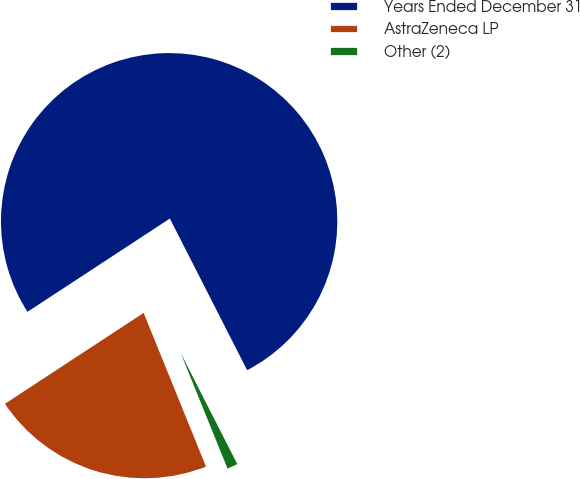<chart> <loc_0><loc_0><loc_500><loc_500><pie_chart><fcel>Years Ended December 31<fcel>AstraZeneca LP<fcel>Other (2)<nl><fcel>76.73%<fcel>21.9%<fcel>1.37%<nl></chart> 